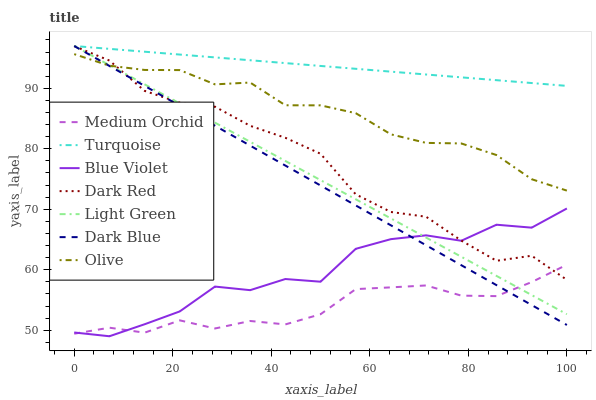Does Medium Orchid have the minimum area under the curve?
Answer yes or no. Yes. Does Turquoise have the maximum area under the curve?
Answer yes or no. Yes. Does Dark Red have the minimum area under the curve?
Answer yes or no. No. Does Dark Red have the maximum area under the curve?
Answer yes or no. No. Is Turquoise the smoothest?
Answer yes or no. Yes. Is Blue Violet the roughest?
Answer yes or no. Yes. Is Dark Red the smoothest?
Answer yes or no. No. Is Dark Red the roughest?
Answer yes or no. No. Does Dark Red have the lowest value?
Answer yes or no. No. Does Light Green have the highest value?
Answer yes or no. Yes. Does Dark Red have the highest value?
Answer yes or no. No. Is Blue Violet less than Turquoise?
Answer yes or no. Yes. Is Turquoise greater than Medium Orchid?
Answer yes or no. Yes. Does Light Green intersect Blue Violet?
Answer yes or no. Yes. Is Light Green less than Blue Violet?
Answer yes or no. No. Is Light Green greater than Blue Violet?
Answer yes or no. No. Does Blue Violet intersect Turquoise?
Answer yes or no. No. 